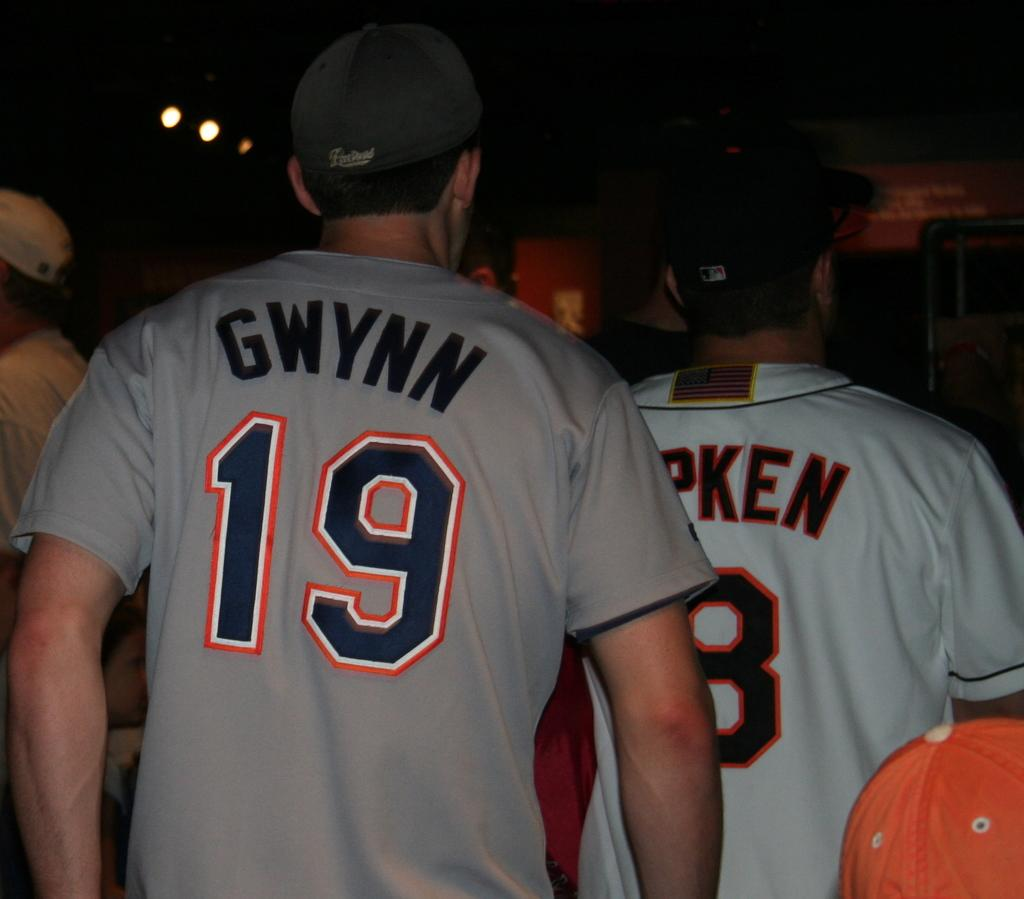<image>
Provide a brief description of the given image. Two men are wearing baseball uniforms and one says Gwynn 19. 